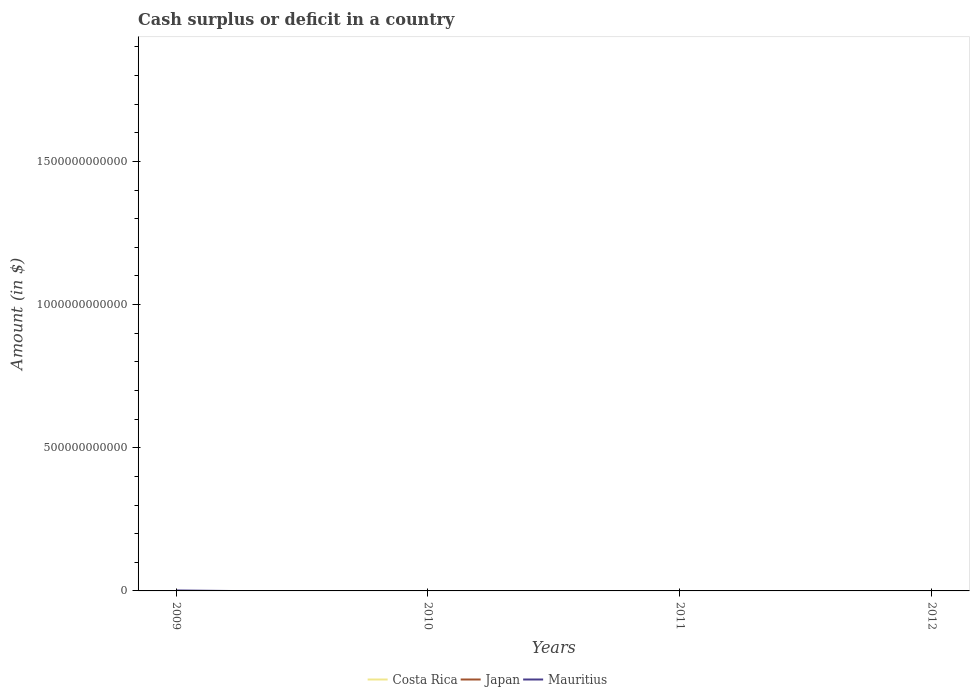How many different coloured lines are there?
Give a very brief answer. 1. Is the number of lines equal to the number of legend labels?
Offer a very short reply. No. Across all years, what is the maximum amount of cash surplus or deficit in Mauritius?
Make the answer very short. 0. What is the difference between the highest and the second highest amount of cash surplus or deficit in Mauritius?
Offer a very short reply. 1.62e+09. What is the difference between the highest and the lowest amount of cash surplus or deficit in Costa Rica?
Make the answer very short. 0. Is the amount of cash surplus or deficit in Mauritius strictly greater than the amount of cash surplus or deficit in Japan over the years?
Provide a succinct answer. No. How many lines are there?
Your answer should be compact. 1. How many years are there in the graph?
Provide a succinct answer. 4. What is the difference between two consecutive major ticks on the Y-axis?
Ensure brevity in your answer.  5.00e+11. Are the values on the major ticks of Y-axis written in scientific E-notation?
Ensure brevity in your answer.  No. Does the graph contain grids?
Make the answer very short. No. Where does the legend appear in the graph?
Provide a short and direct response. Bottom center. What is the title of the graph?
Keep it short and to the point. Cash surplus or deficit in a country. What is the label or title of the Y-axis?
Offer a terse response. Amount (in $). What is the Amount (in $) of Japan in 2009?
Give a very brief answer. 0. What is the Amount (in $) in Mauritius in 2009?
Your response must be concise. 1.62e+09. What is the Amount (in $) in Costa Rica in 2012?
Make the answer very short. 0. What is the Amount (in $) in Mauritius in 2012?
Make the answer very short. 0. Across all years, what is the maximum Amount (in $) in Mauritius?
Ensure brevity in your answer.  1.62e+09. Across all years, what is the minimum Amount (in $) of Mauritius?
Make the answer very short. 0. What is the total Amount (in $) in Japan in the graph?
Give a very brief answer. 0. What is the total Amount (in $) of Mauritius in the graph?
Make the answer very short. 1.62e+09. What is the average Amount (in $) of Mauritius per year?
Provide a succinct answer. 4.06e+08. What is the difference between the highest and the lowest Amount (in $) in Mauritius?
Your answer should be compact. 1.62e+09. 